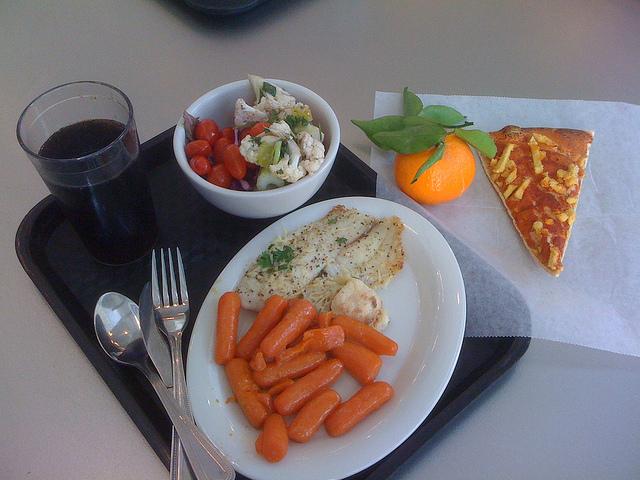What is the fruit that is next to the pizza?
Concise answer only. Orange. What color is the plate?
Give a very brief answer. White. What is the orange vegetable?
Give a very brief answer. Carrots. 